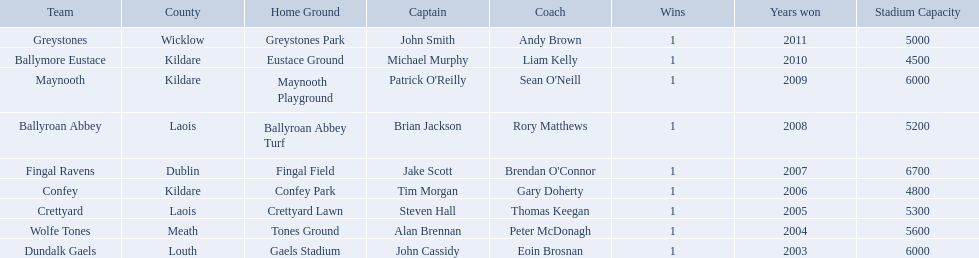What county is the team that won in 2009 from? Kildare. What is the teams name? Maynooth. Where is ballymore eustace from? Kildare. What teams other than ballymore eustace is from kildare? Maynooth, Confey. Between maynooth and confey, which won in 2009? Maynooth. 